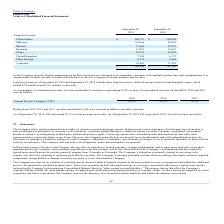From Plexus's financial document, Which years does the table provide information for the company's long-lived assest? The document shows two values: 2019 and 2018. From the document: "Long-lived assets as of September 28, 2019 and September 29, 2018 exclude other long-term assets, deferred income tax assets and intangible as assets ..." Also, What was the amount of long-lived assets in United States in 2019? According to the financial document, 106,757 (in thousands). The relevant text states: "United States $ 106,757 $ 108,694..." Also, What was the amount of long-lived assets in Mexico in 2018? According to the financial document, 43,078 (in thousands). The relevant text states: "Mexico 73,864 43,078..." Additionally, Which countries had long-lived assets that exceed $100,000 thousand in 2019? The document shows two values: United States and Malaysia. From the document: "Malaysia 101,636 89,938 United States $ 106,757 $ 108,694..." Also, can you calculate: What was the change in the long-lived assets in China between 2018 and 2019? Based on the calculation: 22,378-21,878, the result is 500 (in thousands). This is based on the information: "China 22,378 21,878 China 22,378 21,878..." The key data points involved are: 21,878, 22,378. Also, can you calculate: What was the percentage change in the total long-lived assets across all countries between 2018 and 2019? To answer this question, I need to perform calculations using the financial data. The calculation is: (384,224-341,306)/341,306, which equals 12.57 (percentage). This is based on the information: "$ 384,224 $ 341,306 $ 384,224 $ 341,306..." The key data points involved are: 341,306, 384,224. 